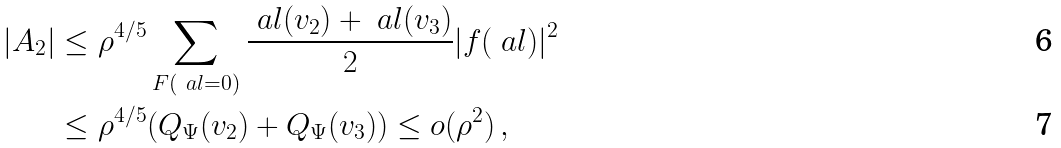Convert formula to latex. <formula><loc_0><loc_0><loc_500><loc_500>| A _ { 2 } | & \leq \rho ^ { 4 / 5 } \sum _ { F ( \ a l = 0 ) } \frac { \ a l ( v _ { 2 } ) + \ a l ( v _ { 3 } ) } 2 | f ( \ a l ) | ^ { 2 } \\ & \leq \rho ^ { 4 / 5 } ( Q _ { \Psi } ( v _ { 2 } ) + Q _ { \Psi } ( v _ { 3 } ) ) \leq o ( \rho ^ { 2 } ) \, ,</formula> 